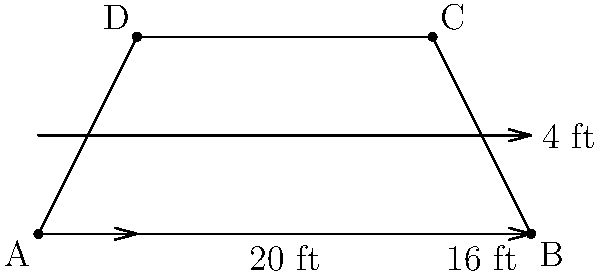Hey, comedy genius! You're about to perform on a uniquely shaped stage that looks like a trapezoid. The stage manager, who's clearly a fan of Daniel Tosh's precise humor, gives you these measurements: the parallel sides are 20 feet and 16 feet long, and the height (or depth) of the stage is 4 feet. What's the total area of this trapezoidal stage where you'll be dropping your hilarious punchlines? Alright, let's break this down step-by-step, just like we dissect a joke:

1) The formula for the area of a trapezoid is:
   $$A = \frac{1}{2}(b_1 + b_2)h$$
   where $A$ is the area, $b_1$ and $b_2$ are the lengths of the parallel sides, and $h$ is the height.

2) We're given:
   $b_1 = 20$ feet (longer parallel side)
   $b_2 = 16$ feet (shorter parallel side)
   $h = 4$ feet (height)

3) Let's plug these values into our formula:
   $$A = \frac{1}{2}(20 + 16) \times 4$$

4) First, add the parallel sides:
   $$A = \frac{1}{2}(36) \times 4$$

5) Multiply:
   $$A = 18 \times 4$$

6) And the final punchline:
   $$A = 72$$

So, the area of your trapezoidal stage is 72 square feet. That's plenty of space for your Daniel Tosh-inspired comedic antics!
Answer: 72 sq ft 